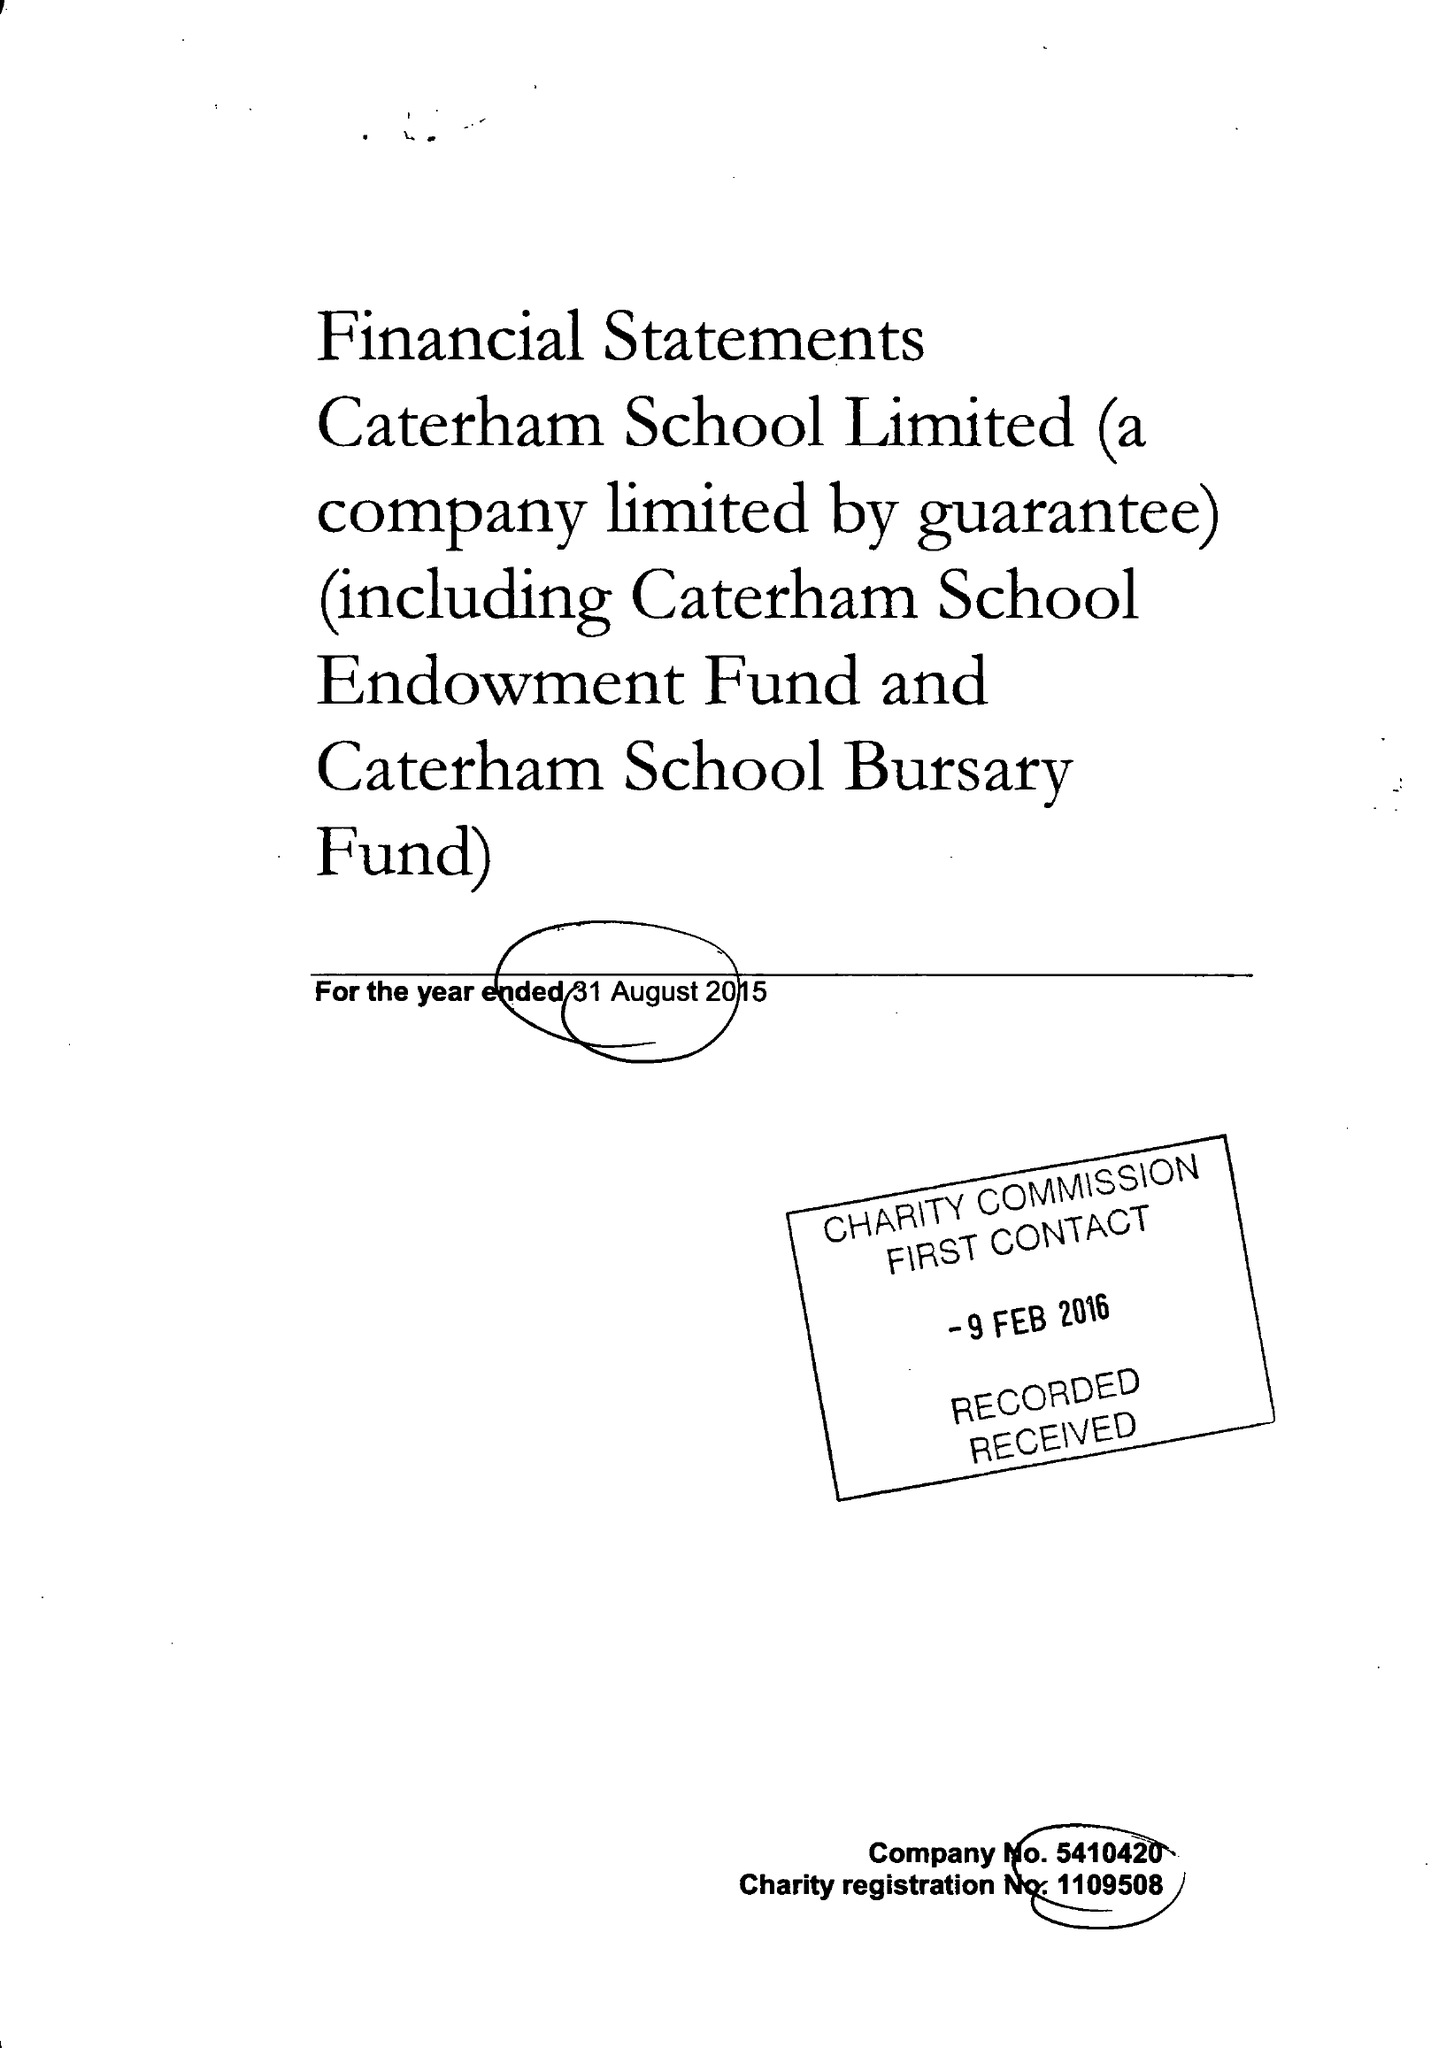What is the value for the charity_number?
Answer the question using a single word or phrase. 1109508 